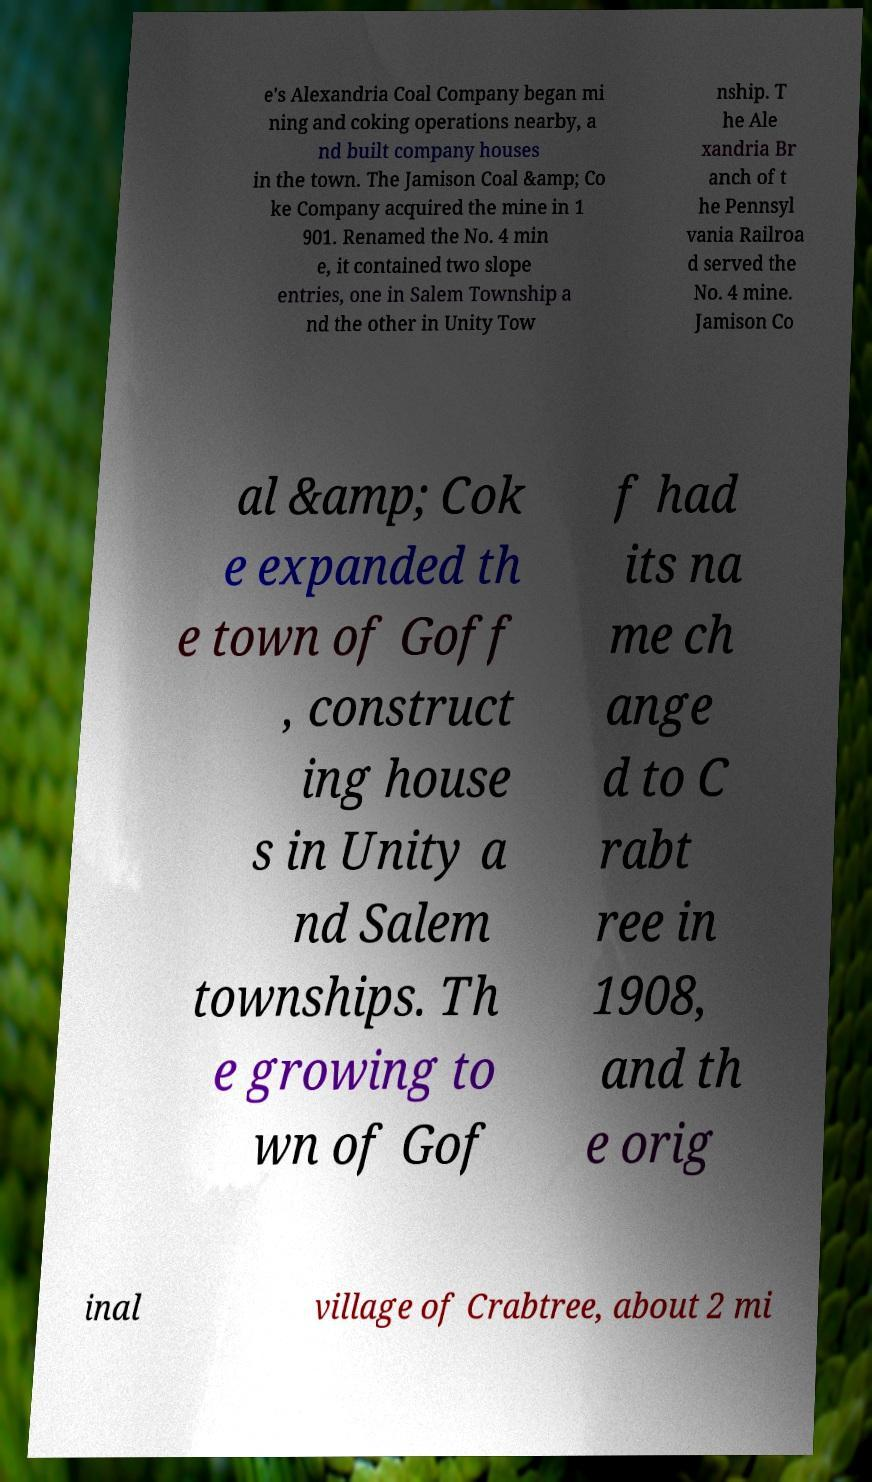Please read and relay the text visible in this image. What does it say? e's Alexandria Coal Company began mi ning and coking operations nearby, a nd built company houses in the town. The Jamison Coal &amp; Co ke Company acquired the mine in 1 901. Renamed the No. 4 min e, it contained two slope entries, one in Salem Township a nd the other in Unity Tow nship. T he Ale xandria Br anch of t he Pennsyl vania Railroa d served the No. 4 mine. Jamison Co al &amp; Cok e expanded th e town of Goff , construct ing house s in Unity a nd Salem townships. Th e growing to wn of Gof f had its na me ch ange d to C rabt ree in 1908, and th e orig inal village of Crabtree, about 2 mi 